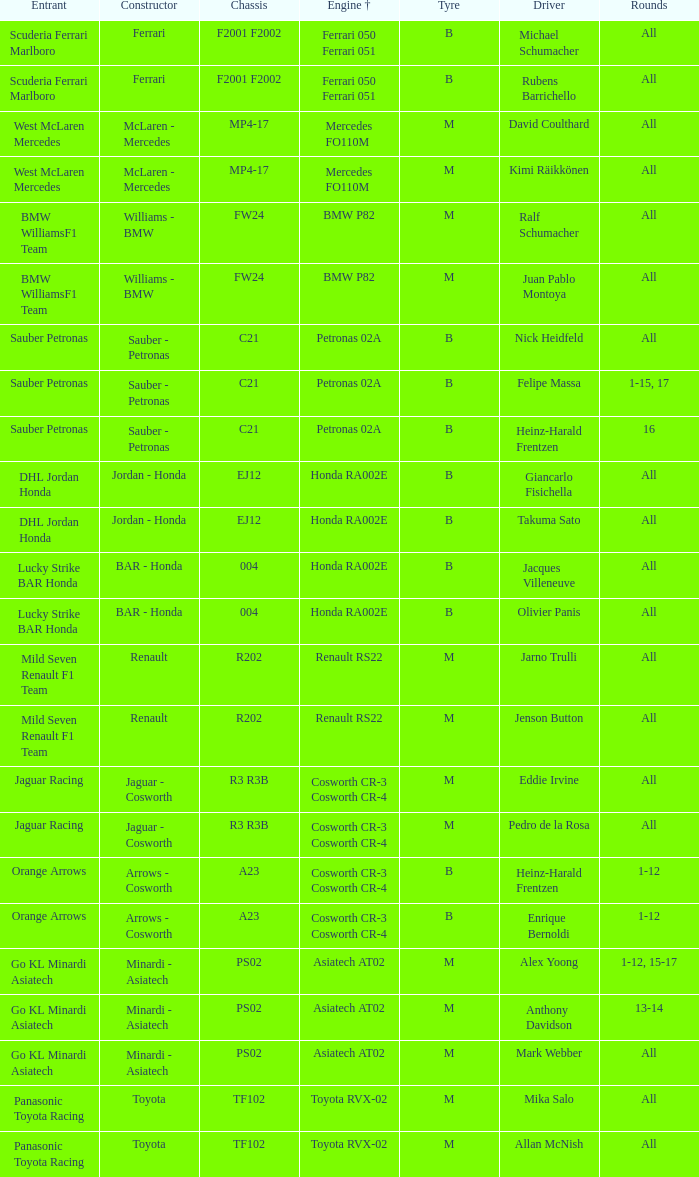When the engine used is bmw p82, who is the participant? BMW WilliamsF1 Team, BMW WilliamsF1 Team. 